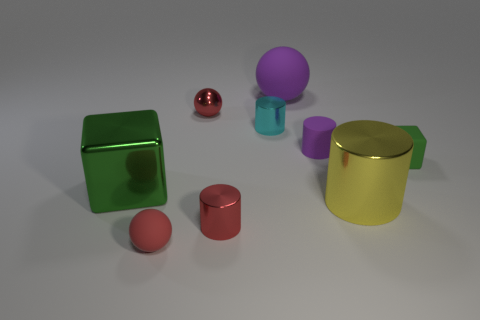Subtract all red spheres. How many spheres are left? 1 Subtract all small cyan cylinders. How many cylinders are left? 3 Subtract all spheres. How many objects are left? 6 Subtract 3 cylinders. How many cylinders are left? 1 Subtract all red cylinders. Subtract all blue blocks. How many cylinders are left? 3 Subtract all cyan balls. How many green cylinders are left? 0 Subtract all big yellow metallic cylinders. Subtract all green objects. How many objects are left? 6 Add 7 purple things. How many purple things are left? 9 Add 2 tiny green things. How many tiny green things exist? 3 Subtract 1 green blocks. How many objects are left? 8 